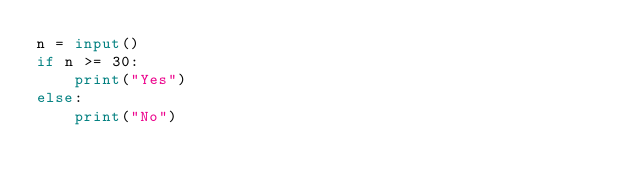Convert code to text. <code><loc_0><loc_0><loc_500><loc_500><_Python_>n = input()
if n >= 30:
    print("Yes")
else:
    print("No")</code> 